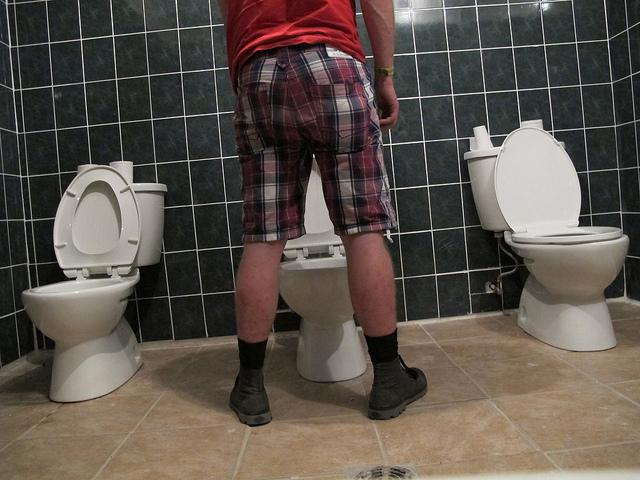Which room is this? bathroom 